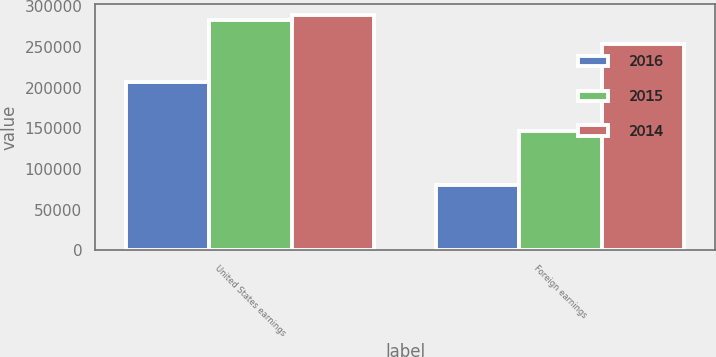Convert chart. <chart><loc_0><loc_0><loc_500><loc_500><stacked_bar_chart><ecel><fcel>United States earnings<fcel>Foreign earnings<nl><fcel>2016<fcel>206159<fcel>80564<nl><fcel>2015<fcel>283504<fcel>146633<nl><fcel>2014<fcel>288800<fcel>253366<nl></chart> 